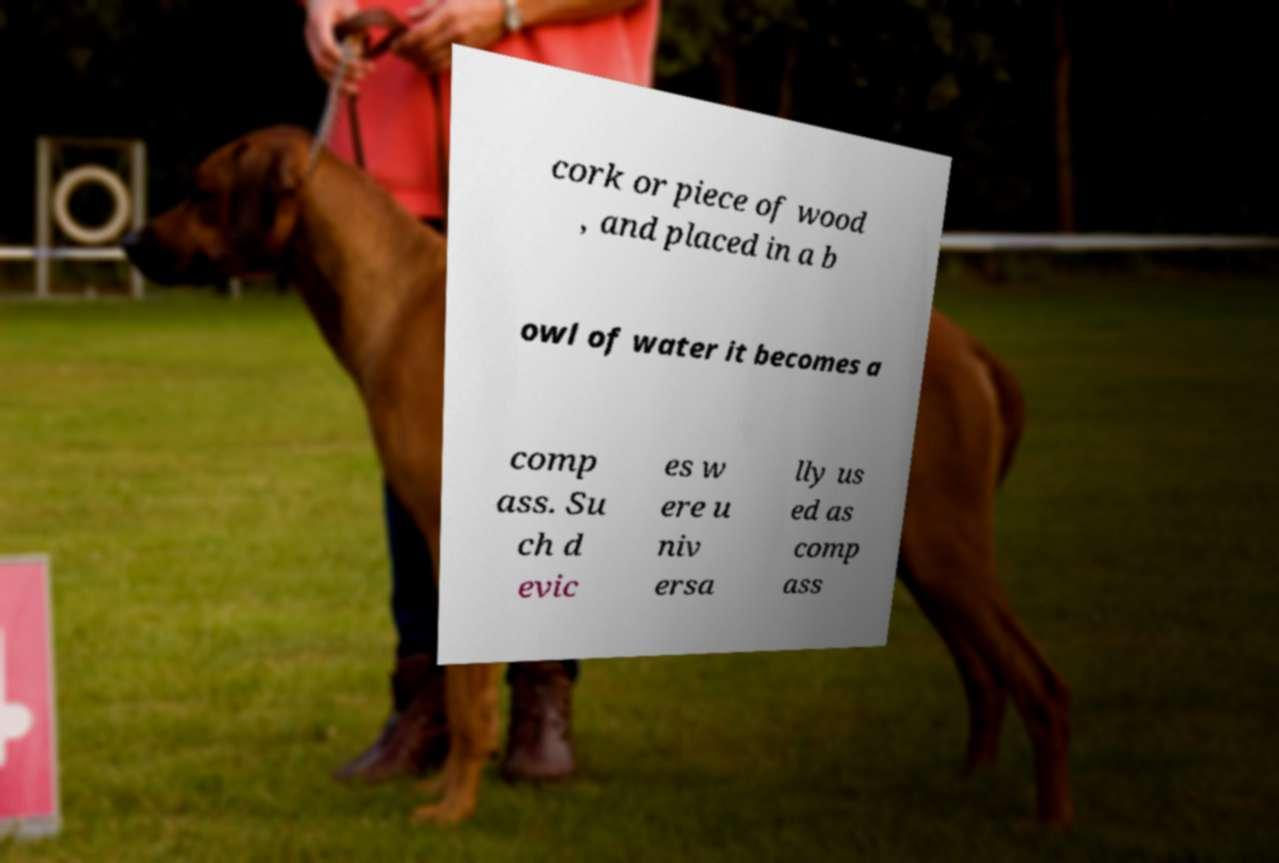For documentation purposes, I need the text within this image transcribed. Could you provide that? cork or piece of wood , and placed in a b owl of water it becomes a comp ass. Su ch d evic es w ere u niv ersa lly us ed as comp ass 